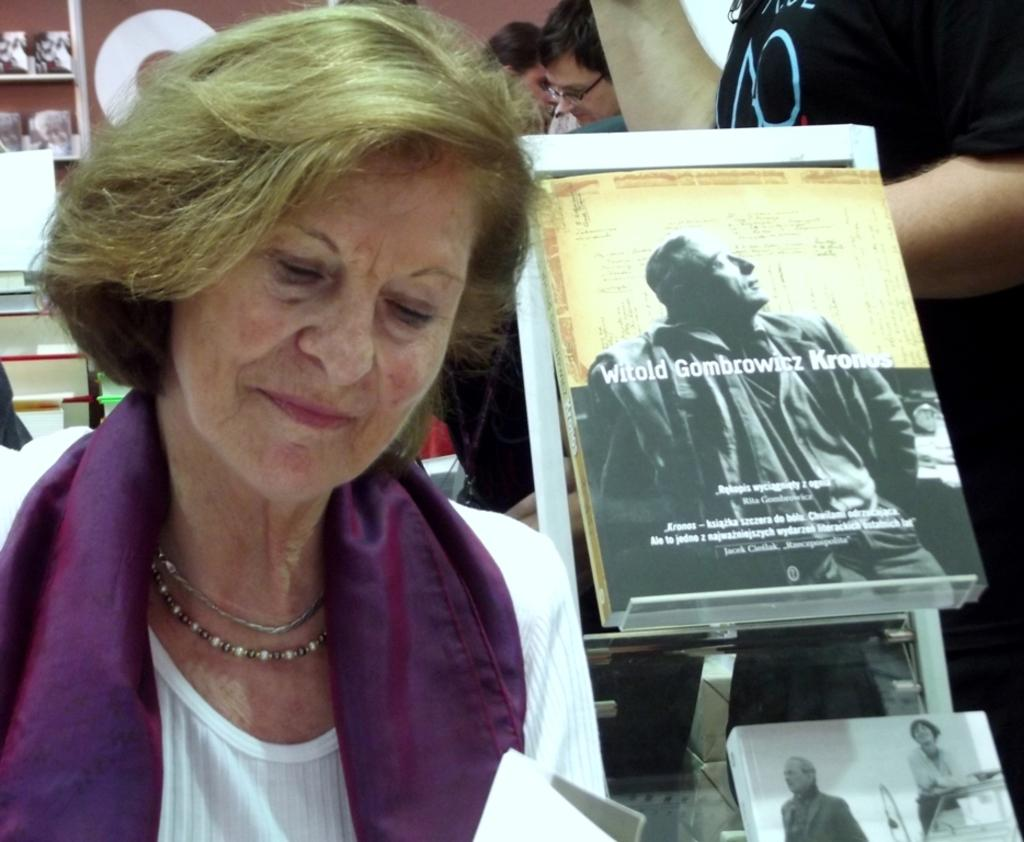Who or what can be seen in the image? There are people in the image. What can be found on a rack in the image? There are books on a rack in the image. What is located on the left side of the image? There are objects on the left side of the image. How many cherries are on the chin of the person in the image? There are no cherries present in the image, and no one's chin is visible. Is there a bear visible in the image? There is no bear present in the image. 